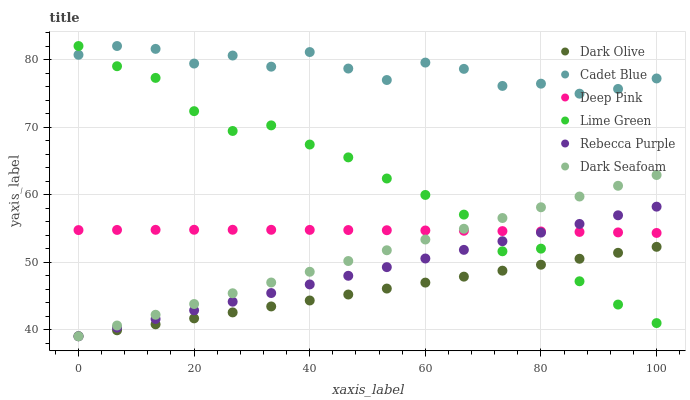Does Dark Olive have the minimum area under the curve?
Answer yes or no. Yes. Does Cadet Blue have the maximum area under the curve?
Answer yes or no. Yes. Does Dark Seafoam have the minimum area under the curve?
Answer yes or no. No. Does Dark Seafoam have the maximum area under the curve?
Answer yes or no. No. Is Rebecca Purple the smoothest?
Answer yes or no. Yes. Is Cadet Blue the roughest?
Answer yes or no. Yes. Is Dark Olive the smoothest?
Answer yes or no. No. Is Dark Olive the roughest?
Answer yes or no. No. Does Dark Olive have the lowest value?
Answer yes or no. Yes. Does Deep Pink have the lowest value?
Answer yes or no. No. Does Lime Green have the highest value?
Answer yes or no. Yes. Does Dark Seafoam have the highest value?
Answer yes or no. No. Is Rebecca Purple less than Cadet Blue?
Answer yes or no. Yes. Is Cadet Blue greater than Rebecca Purple?
Answer yes or no. Yes. Does Dark Seafoam intersect Lime Green?
Answer yes or no. Yes. Is Dark Seafoam less than Lime Green?
Answer yes or no. No. Is Dark Seafoam greater than Lime Green?
Answer yes or no. No. Does Rebecca Purple intersect Cadet Blue?
Answer yes or no. No. 